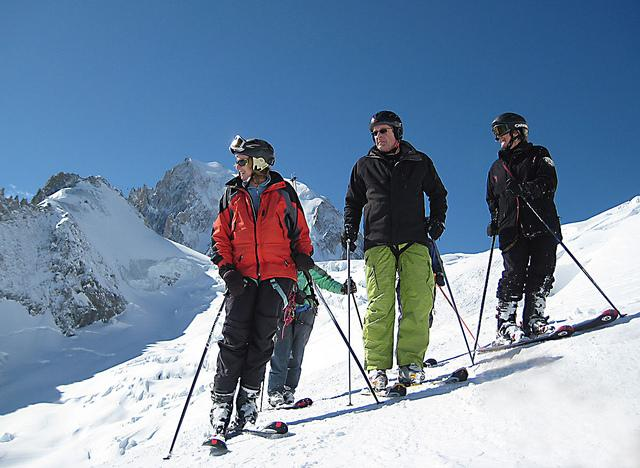What are they ready to do here? ski 